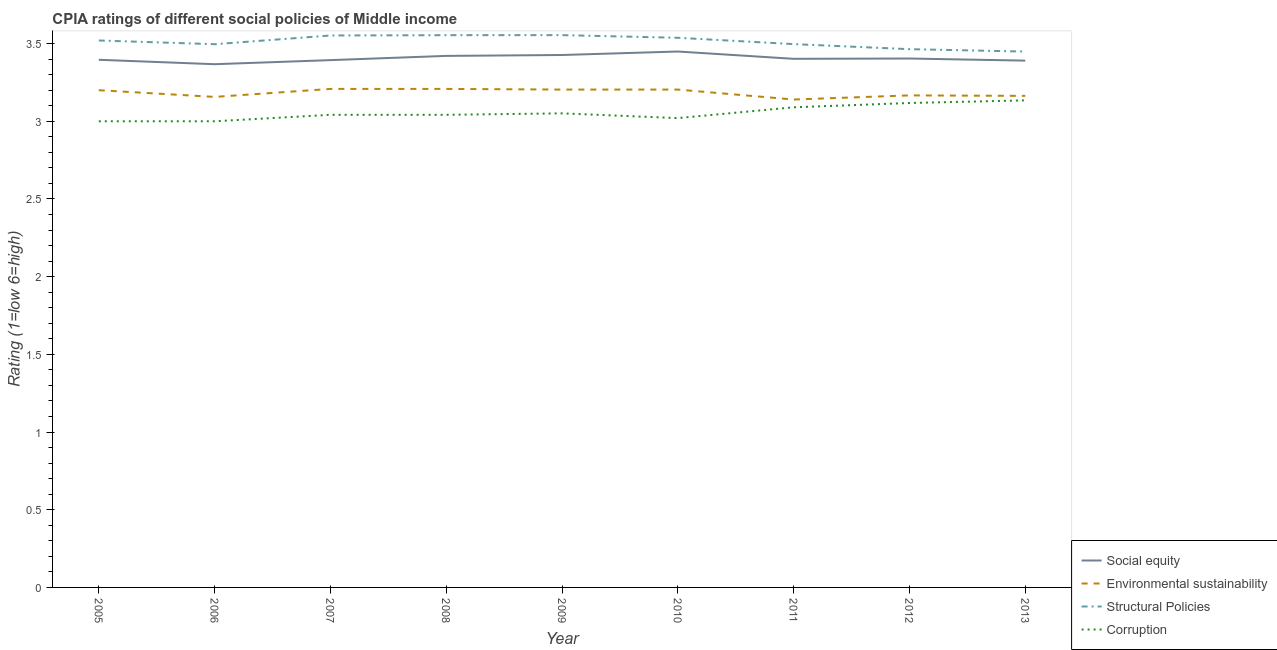How many different coloured lines are there?
Offer a very short reply. 4. Is the number of lines equal to the number of legend labels?
Provide a short and direct response. Yes. What is the cpia rating of corruption in 2009?
Keep it short and to the point. 3.05. Across all years, what is the maximum cpia rating of environmental sustainability?
Ensure brevity in your answer.  3.21. In which year was the cpia rating of environmental sustainability maximum?
Offer a terse response. 2007. In which year was the cpia rating of social equity minimum?
Your answer should be very brief. 2006. What is the total cpia rating of social equity in the graph?
Your answer should be compact. 30.65. What is the difference between the cpia rating of social equity in 2006 and that in 2007?
Your response must be concise. -0.03. What is the difference between the cpia rating of environmental sustainability in 2011 and the cpia rating of structural policies in 2013?
Your answer should be compact. -0.31. What is the average cpia rating of corruption per year?
Give a very brief answer. 3.06. In the year 2007, what is the difference between the cpia rating of social equity and cpia rating of environmental sustainability?
Your answer should be compact. 0.19. What is the ratio of the cpia rating of structural policies in 2009 to that in 2011?
Offer a very short reply. 1.02. Is the cpia rating of corruption in 2005 less than that in 2013?
Provide a short and direct response. Yes. Is the difference between the cpia rating of environmental sustainability in 2008 and 2012 greater than the difference between the cpia rating of corruption in 2008 and 2012?
Make the answer very short. Yes. What is the difference between the highest and the second highest cpia rating of structural policies?
Keep it short and to the point. 0. What is the difference between the highest and the lowest cpia rating of structural policies?
Provide a short and direct response. 0.11. Is the sum of the cpia rating of social equity in 2007 and 2010 greater than the maximum cpia rating of structural policies across all years?
Ensure brevity in your answer.  Yes. Is it the case that in every year, the sum of the cpia rating of social equity and cpia rating of environmental sustainability is greater than the cpia rating of structural policies?
Your answer should be compact. Yes. Is the cpia rating of social equity strictly less than the cpia rating of corruption over the years?
Your answer should be very brief. No. Does the graph contain grids?
Your answer should be very brief. No. How many legend labels are there?
Your answer should be compact. 4. How are the legend labels stacked?
Provide a short and direct response. Vertical. What is the title of the graph?
Offer a very short reply. CPIA ratings of different social policies of Middle income. What is the label or title of the Y-axis?
Make the answer very short. Rating (1=low 6=high). What is the Rating (1=low 6=high) in Social equity in 2005?
Ensure brevity in your answer.  3.4. What is the Rating (1=low 6=high) in Structural Policies in 2005?
Keep it short and to the point. 3.52. What is the Rating (1=low 6=high) of Corruption in 2005?
Offer a terse response. 3. What is the Rating (1=low 6=high) in Social equity in 2006?
Your answer should be very brief. 3.37. What is the Rating (1=low 6=high) in Environmental sustainability in 2006?
Offer a very short reply. 3.16. What is the Rating (1=low 6=high) in Structural Policies in 2006?
Your answer should be compact. 3.5. What is the Rating (1=low 6=high) in Corruption in 2006?
Your answer should be very brief. 3. What is the Rating (1=low 6=high) in Social equity in 2007?
Your response must be concise. 3.39. What is the Rating (1=low 6=high) in Environmental sustainability in 2007?
Keep it short and to the point. 3.21. What is the Rating (1=low 6=high) in Structural Policies in 2007?
Keep it short and to the point. 3.55. What is the Rating (1=low 6=high) in Corruption in 2007?
Offer a terse response. 3.04. What is the Rating (1=low 6=high) of Social equity in 2008?
Make the answer very short. 3.42. What is the Rating (1=low 6=high) in Environmental sustainability in 2008?
Give a very brief answer. 3.21. What is the Rating (1=low 6=high) of Structural Policies in 2008?
Offer a very short reply. 3.55. What is the Rating (1=low 6=high) of Corruption in 2008?
Your response must be concise. 3.04. What is the Rating (1=low 6=high) of Social equity in 2009?
Keep it short and to the point. 3.43. What is the Rating (1=low 6=high) of Environmental sustainability in 2009?
Offer a very short reply. 3.2. What is the Rating (1=low 6=high) in Structural Policies in 2009?
Provide a short and direct response. 3.55. What is the Rating (1=low 6=high) of Corruption in 2009?
Offer a terse response. 3.05. What is the Rating (1=low 6=high) in Social equity in 2010?
Provide a succinct answer. 3.45. What is the Rating (1=low 6=high) in Environmental sustainability in 2010?
Provide a succinct answer. 3.2. What is the Rating (1=low 6=high) of Structural Policies in 2010?
Keep it short and to the point. 3.54. What is the Rating (1=low 6=high) of Corruption in 2010?
Offer a very short reply. 3.02. What is the Rating (1=low 6=high) in Social equity in 2011?
Provide a short and direct response. 3.4. What is the Rating (1=low 6=high) in Environmental sustainability in 2011?
Offer a very short reply. 3.14. What is the Rating (1=low 6=high) in Structural Policies in 2011?
Your answer should be very brief. 3.5. What is the Rating (1=low 6=high) in Corruption in 2011?
Your answer should be compact. 3.09. What is the Rating (1=low 6=high) of Social equity in 2012?
Make the answer very short. 3.4. What is the Rating (1=low 6=high) of Environmental sustainability in 2012?
Give a very brief answer. 3.17. What is the Rating (1=low 6=high) in Structural Policies in 2012?
Provide a short and direct response. 3.46. What is the Rating (1=low 6=high) in Corruption in 2012?
Provide a short and direct response. 3.12. What is the Rating (1=low 6=high) in Social equity in 2013?
Your answer should be compact. 3.39. What is the Rating (1=low 6=high) of Environmental sustainability in 2013?
Your answer should be compact. 3.16. What is the Rating (1=low 6=high) in Structural Policies in 2013?
Your response must be concise. 3.45. What is the Rating (1=low 6=high) of Corruption in 2013?
Your response must be concise. 3.13. Across all years, what is the maximum Rating (1=low 6=high) of Social equity?
Your answer should be compact. 3.45. Across all years, what is the maximum Rating (1=low 6=high) of Environmental sustainability?
Your response must be concise. 3.21. Across all years, what is the maximum Rating (1=low 6=high) in Structural Policies?
Your answer should be very brief. 3.55. Across all years, what is the maximum Rating (1=low 6=high) in Corruption?
Your answer should be very brief. 3.13. Across all years, what is the minimum Rating (1=low 6=high) in Social equity?
Provide a short and direct response. 3.37. Across all years, what is the minimum Rating (1=low 6=high) of Environmental sustainability?
Keep it short and to the point. 3.14. Across all years, what is the minimum Rating (1=low 6=high) of Structural Policies?
Your answer should be very brief. 3.45. Across all years, what is the minimum Rating (1=low 6=high) of Corruption?
Ensure brevity in your answer.  3. What is the total Rating (1=low 6=high) in Social equity in the graph?
Ensure brevity in your answer.  30.65. What is the total Rating (1=low 6=high) in Environmental sustainability in the graph?
Keep it short and to the point. 28.65. What is the total Rating (1=low 6=high) in Structural Policies in the graph?
Keep it short and to the point. 31.62. What is the total Rating (1=low 6=high) in Corruption in the graph?
Offer a very short reply. 27.5. What is the difference between the Rating (1=low 6=high) in Social equity in 2005 and that in 2006?
Keep it short and to the point. 0.03. What is the difference between the Rating (1=low 6=high) in Environmental sustainability in 2005 and that in 2006?
Your response must be concise. 0.04. What is the difference between the Rating (1=low 6=high) of Structural Policies in 2005 and that in 2006?
Offer a very short reply. 0.02. What is the difference between the Rating (1=low 6=high) of Corruption in 2005 and that in 2006?
Your answer should be compact. 0. What is the difference between the Rating (1=low 6=high) in Social equity in 2005 and that in 2007?
Give a very brief answer. 0. What is the difference between the Rating (1=low 6=high) in Environmental sustainability in 2005 and that in 2007?
Provide a succinct answer. -0.01. What is the difference between the Rating (1=low 6=high) in Structural Policies in 2005 and that in 2007?
Your answer should be very brief. -0.03. What is the difference between the Rating (1=low 6=high) in Corruption in 2005 and that in 2007?
Keep it short and to the point. -0.04. What is the difference between the Rating (1=low 6=high) of Social equity in 2005 and that in 2008?
Keep it short and to the point. -0.03. What is the difference between the Rating (1=low 6=high) in Environmental sustainability in 2005 and that in 2008?
Provide a succinct answer. -0.01. What is the difference between the Rating (1=low 6=high) in Structural Policies in 2005 and that in 2008?
Make the answer very short. -0.03. What is the difference between the Rating (1=low 6=high) in Corruption in 2005 and that in 2008?
Your response must be concise. -0.04. What is the difference between the Rating (1=low 6=high) of Social equity in 2005 and that in 2009?
Provide a succinct answer. -0.03. What is the difference between the Rating (1=low 6=high) in Environmental sustainability in 2005 and that in 2009?
Offer a terse response. -0. What is the difference between the Rating (1=low 6=high) in Structural Policies in 2005 and that in 2009?
Make the answer very short. -0.03. What is the difference between the Rating (1=low 6=high) of Corruption in 2005 and that in 2009?
Your answer should be very brief. -0.05. What is the difference between the Rating (1=low 6=high) in Social equity in 2005 and that in 2010?
Ensure brevity in your answer.  -0.05. What is the difference between the Rating (1=low 6=high) of Environmental sustainability in 2005 and that in 2010?
Give a very brief answer. -0. What is the difference between the Rating (1=low 6=high) of Structural Policies in 2005 and that in 2010?
Offer a very short reply. -0.02. What is the difference between the Rating (1=low 6=high) of Corruption in 2005 and that in 2010?
Offer a terse response. -0.02. What is the difference between the Rating (1=low 6=high) in Social equity in 2005 and that in 2011?
Make the answer very short. -0.01. What is the difference between the Rating (1=low 6=high) of Environmental sustainability in 2005 and that in 2011?
Make the answer very short. 0.06. What is the difference between the Rating (1=low 6=high) in Structural Policies in 2005 and that in 2011?
Your answer should be compact. 0.02. What is the difference between the Rating (1=low 6=high) of Corruption in 2005 and that in 2011?
Offer a very short reply. -0.09. What is the difference between the Rating (1=low 6=high) of Social equity in 2005 and that in 2012?
Ensure brevity in your answer.  -0.01. What is the difference between the Rating (1=low 6=high) in Environmental sustainability in 2005 and that in 2012?
Make the answer very short. 0.03. What is the difference between the Rating (1=low 6=high) in Structural Policies in 2005 and that in 2012?
Your answer should be compact. 0.06. What is the difference between the Rating (1=low 6=high) in Corruption in 2005 and that in 2012?
Give a very brief answer. -0.12. What is the difference between the Rating (1=low 6=high) in Social equity in 2005 and that in 2013?
Ensure brevity in your answer.  0.01. What is the difference between the Rating (1=low 6=high) in Environmental sustainability in 2005 and that in 2013?
Provide a short and direct response. 0.04. What is the difference between the Rating (1=low 6=high) in Structural Policies in 2005 and that in 2013?
Your answer should be very brief. 0.07. What is the difference between the Rating (1=low 6=high) in Corruption in 2005 and that in 2013?
Offer a terse response. -0.13. What is the difference between the Rating (1=low 6=high) of Social equity in 2006 and that in 2007?
Provide a short and direct response. -0.03. What is the difference between the Rating (1=low 6=high) in Environmental sustainability in 2006 and that in 2007?
Keep it short and to the point. -0.05. What is the difference between the Rating (1=low 6=high) of Structural Policies in 2006 and that in 2007?
Your answer should be compact. -0.06. What is the difference between the Rating (1=low 6=high) of Corruption in 2006 and that in 2007?
Keep it short and to the point. -0.04. What is the difference between the Rating (1=low 6=high) of Social equity in 2006 and that in 2008?
Your answer should be very brief. -0.05. What is the difference between the Rating (1=low 6=high) in Environmental sustainability in 2006 and that in 2008?
Give a very brief answer. -0.05. What is the difference between the Rating (1=low 6=high) in Structural Policies in 2006 and that in 2008?
Offer a terse response. -0.06. What is the difference between the Rating (1=low 6=high) of Corruption in 2006 and that in 2008?
Give a very brief answer. -0.04. What is the difference between the Rating (1=low 6=high) in Social equity in 2006 and that in 2009?
Provide a succinct answer. -0.06. What is the difference between the Rating (1=low 6=high) of Environmental sustainability in 2006 and that in 2009?
Offer a terse response. -0.05. What is the difference between the Rating (1=low 6=high) of Structural Policies in 2006 and that in 2009?
Make the answer very short. -0.06. What is the difference between the Rating (1=low 6=high) in Corruption in 2006 and that in 2009?
Offer a very short reply. -0.05. What is the difference between the Rating (1=low 6=high) of Social equity in 2006 and that in 2010?
Provide a short and direct response. -0.08. What is the difference between the Rating (1=low 6=high) of Environmental sustainability in 2006 and that in 2010?
Provide a short and direct response. -0.05. What is the difference between the Rating (1=low 6=high) of Structural Policies in 2006 and that in 2010?
Give a very brief answer. -0.04. What is the difference between the Rating (1=low 6=high) in Corruption in 2006 and that in 2010?
Provide a succinct answer. -0.02. What is the difference between the Rating (1=low 6=high) of Social equity in 2006 and that in 2011?
Keep it short and to the point. -0.03. What is the difference between the Rating (1=low 6=high) of Environmental sustainability in 2006 and that in 2011?
Your answer should be very brief. 0.02. What is the difference between the Rating (1=low 6=high) in Structural Policies in 2006 and that in 2011?
Provide a succinct answer. -0. What is the difference between the Rating (1=low 6=high) in Corruption in 2006 and that in 2011?
Give a very brief answer. -0.09. What is the difference between the Rating (1=low 6=high) of Social equity in 2006 and that in 2012?
Provide a short and direct response. -0.04. What is the difference between the Rating (1=low 6=high) of Environmental sustainability in 2006 and that in 2012?
Offer a terse response. -0.01. What is the difference between the Rating (1=low 6=high) in Structural Policies in 2006 and that in 2012?
Make the answer very short. 0.03. What is the difference between the Rating (1=low 6=high) in Corruption in 2006 and that in 2012?
Ensure brevity in your answer.  -0.12. What is the difference between the Rating (1=low 6=high) in Social equity in 2006 and that in 2013?
Provide a succinct answer. -0.02. What is the difference between the Rating (1=low 6=high) in Environmental sustainability in 2006 and that in 2013?
Give a very brief answer. -0.01. What is the difference between the Rating (1=low 6=high) in Structural Policies in 2006 and that in 2013?
Keep it short and to the point. 0.05. What is the difference between the Rating (1=low 6=high) in Corruption in 2006 and that in 2013?
Give a very brief answer. -0.13. What is the difference between the Rating (1=low 6=high) in Social equity in 2007 and that in 2008?
Provide a short and direct response. -0.03. What is the difference between the Rating (1=low 6=high) in Environmental sustainability in 2007 and that in 2008?
Make the answer very short. 0. What is the difference between the Rating (1=low 6=high) in Structural Policies in 2007 and that in 2008?
Make the answer very short. -0. What is the difference between the Rating (1=low 6=high) of Corruption in 2007 and that in 2008?
Make the answer very short. 0. What is the difference between the Rating (1=low 6=high) in Social equity in 2007 and that in 2009?
Provide a short and direct response. -0.03. What is the difference between the Rating (1=low 6=high) of Environmental sustainability in 2007 and that in 2009?
Provide a succinct answer. 0. What is the difference between the Rating (1=low 6=high) of Structural Policies in 2007 and that in 2009?
Ensure brevity in your answer.  -0. What is the difference between the Rating (1=low 6=high) in Corruption in 2007 and that in 2009?
Your answer should be very brief. -0.01. What is the difference between the Rating (1=low 6=high) in Social equity in 2007 and that in 2010?
Your answer should be very brief. -0.06. What is the difference between the Rating (1=low 6=high) of Environmental sustainability in 2007 and that in 2010?
Keep it short and to the point. 0. What is the difference between the Rating (1=low 6=high) in Structural Policies in 2007 and that in 2010?
Make the answer very short. 0.01. What is the difference between the Rating (1=low 6=high) in Corruption in 2007 and that in 2010?
Make the answer very short. 0.02. What is the difference between the Rating (1=low 6=high) in Social equity in 2007 and that in 2011?
Ensure brevity in your answer.  -0.01. What is the difference between the Rating (1=low 6=high) in Environmental sustainability in 2007 and that in 2011?
Keep it short and to the point. 0.07. What is the difference between the Rating (1=low 6=high) in Structural Policies in 2007 and that in 2011?
Provide a succinct answer. 0.06. What is the difference between the Rating (1=low 6=high) of Corruption in 2007 and that in 2011?
Provide a succinct answer. -0.05. What is the difference between the Rating (1=low 6=high) of Social equity in 2007 and that in 2012?
Your answer should be compact. -0.01. What is the difference between the Rating (1=low 6=high) of Environmental sustainability in 2007 and that in 2012?
Make the answer very short. 0.04. What is the difference between the Rating (1=low 6=high) of Structural Policies in 2007 and that in 2012?
Make the answer very short. 0.09. What is the difference between the Rating (1=low 6=high) in Corruption in 2007 and that in 2012?
Your response must be concise. -0.08. What is the difference between the Rating (1=low 6=high) in Social equity in 2007 and that in 2013?
Make the answer very short. 0. What is the difference between the Rating (1=low 6=high) of Environmental sustainability in 2007 and that in 2013?
Your response must be concise. 0.04. What is the difference between the Rating (1=low 6=high) of Structural Policies in 2007 and that in 2013?
Give a very brief answer. 0.1. What is the difference between the Rating (1=low 6=high) of Corruption in 2007 and that in 2013?
Your answer should be very brief. -0.09. What is the difference between the Rating (1=low 6=high) in Social equity in 2008 and that in 2009?
Ensure brevity in your answer.  -0.01. What is the difference between the Rating (1=low 6=high) in Environmental sustainability in 2008 and that in 2009?
Give a very brief answer. 0. What is the difference between the Rating (1=low 6=high) in Structural Policies in 2008 and that in 2009?
Offer a very short reply. -0. What is the difference between the Rating (1=low 6=high) of Corruption in 2008 and that in 2009?
Make the answer very short. -0.01. What is the difference between the Rating (1=low 6=high) in Social equity in 2008 and that in 2010?
Your answer should be compact. -0.03. What is the difference between the Rating (1=low 6=high) in Environmental sustainability in 2008 and that in 2010?
Make the answer very short. 0. What is the difference between the Rating (1=low 6=high) in Structural Policies in 2008 and that in 2010?
Provide a succinct answer. 0.02. What is the difference between the Rating (1=low 6=high) of Corruption in 2008 and that in 2010?
Offer a very short reply. 0.02. What is the difference between the Rating (1=low 6=high) of Social equity in 2008 and that in 2011?
Provide a short and direct response. 0.02. What is the difference between the Rating (1=low 6=high) of Environmental sustainability in 2008 and that in 2011?
Your response must be concise. 0.07. What is the difference between the Rating (1=low 6=high) in Structural Policies in 2008 and that in 2011?
Keep it short and to the point. 0.06. What is the difference between the Rating (1=low 6=high) of Corruption in 2008 and that in 2011?
Your response must be concise. -0.05. What is the difference between the Rating (1=low 6=high) in Social equity in 2008 and that in 2012?
Offer a very short reply. 0.02. What is the difference between the Rating (1=low 6=high) of Environmental sustainability in 2008 and that in 2012?
Make the answer very short. 0.04. What is the difference between the Rating (1=low 6=high) in Structural Policies in 2008 and that in 2012?
Offer a terse response. 0.09. What is the difference between the Rating (1=low 6=high) in Corruption in 2008 and that in 2012?
Give a very brief answer. -0.08. What is the difference between the Rating (1=low 6=high) in Social equity in 2008 and that in 2013?
Keep it short and to the point. 0.03. What is the difference between the Rating (1=low 6=high) in Environmental sustainability in 2008 and that in 2013?
Your answer should be compact. 0.04. What is the difference between the Rating (1=low 6=high) of Structural Policies in 2008 and that in 2013?
Keep it short and to the point. 0.11. What is the difference between the Rating (1=low 6=high) in Corruption in 2008 and that in 2013?
Keep it short and to the point. -0.09. What is the difference between the Rating (1=low 6=high) of Social equity in 2009 and that in 2010?
Offer a terse response. -0.02. What is the difference between the Rating (1=low 6=high) in Structural Policies in 2009 and that in 2010?
Your answer should be compact. 0.02. What is the difference between the Rating (1=low 6=high) in Corruption in 2009 and that in 2010?
Your response must be concise. 0.03. What is the difference between the Rating (1=low 6=high) of Social equity in 2009 and that in 2011?
Provide a succinct answer. 0.02. What is the difference between the Rating (1=low 6=high) in Environmental sustainability in 2009 and that in 2011?
Provide a short and direct response. 0.06. What is the difference between the Rating (1=low 6=high) of Structural Policies in 2009 and that in 2011?
Your answer should be very brief. 0.06. What is the difference between the Rating (1=low 6=high) in Corruption in 2009 and that in 2011?
Your response must be concise. -0.04. What is the difference between the Rating (1=low 6=high) of Social equity in 2009 and that in 2012?
Your response must be concise. 0.02. What is the difference between the Rating (1=low 6=high) of Environmental sustainability in 2009 and that in 2012?
Provide a short and direct response. 0.04. What is the difference between the Rating (1=low 6=high) in Structural Policies in 2009 and that in 2012?
Your answer should be compact. 0.09. What is the difference between the Rating (1=low 6=high) in Corruption in 2009 and that in 2012?
Make the answer very short. -0.07. What is the difference between the Rating (1=low 6=high) in Social equity in 2009 and that in 2013?
Your answer should be very brief. 0.04. What is the difference between the Rating (1=low 6=high) in Environmental sustainability in 2009 and that in 2013?
Give a very brief answer. 0.04. What is the difference between the Rating (1=low 6=high) in Structural Policies in 2009 and that in 2013?
Provide a succinct answer. 0.11. What is the difference between the Rating (1=low 6=high) of Corruption in 2009 and that in 2013?
Offer a very short reply. -0.08. What is the difference between the Rating (1=low 6=high) in Social equity in 2010 and that in 2011?
Ensure brevity in your answer.  0.05. What is the difference between the Rating (1=low 6=high) of Environmental sustainability in 2010 and that in 2011?
Keep it short and to the point. 0.06. What is the difference between the Rating (1=low 6=high) of Structural Policies in 2010 and that in 2011?
Offer a very short reply. 0.04. What is the difference between the Rating (1=low 6=high) in Corruption in 2010 and that in 2011?
Provide a short and direct response. -0.07. What is the difference between the Rating (1=low 6=high) of Social equity in 2010 and that in 2012?
Ensure brevity in your answer.  0.05. What is the difference between the Rating (1=low 6=high) in Environmental sustainability in 2010 and that in 2012?
Offer a very short reply. 0.04. What is the difference between the Rating (1=low 6=high) in Structural Policies in 2010 and that in 2012?
Give a very brief answer. 0.07. What is the difference between the Rating (1=low 6=high) of Corruption in 2010 and that in 2012?
Offer a very short reply. -0.1. What is the difference between the Rating (1=low 6=high) of Social equity in 2010 and that in 2013?
Offer a terse response. 0.06. What is the difference between the Rating (1=low 6=high) in Environmental sustainability in 2010 and that in 2013?
Your response must be concise. 0.04. What is the difference between the Rating (1=low 6=high) in Structural Policies in 2010 and that in 2013?
Give a very brief answer. 0.09. What is the difference between the Rating (1=low 6=high) of Corruption in 2010 and that in 2013?
Ensure brevity in your answer.  -0.11. What is the difference between the Rating (1=low 6=high) of Social equity in 2011 and that in 2012?
Provide a succinct answer. -0. What is the difference between the Rating (1=low 6=high) of Environmental sustainability in 2011 and that in 2012?
Provide a succinct answer. -0.03. What is the difference between the Rating (1=low 6=high) in Structural Policies in 2011 and that in 2012?
Keep it short and to the point. 0.03. What is the difference between the Rating (1=low 6=high) in Corruption in 2011 and that in 2012?
Provide a short and direct response. -0.03. What is the difference between the Rating (1=low 6=high) in Social equity in 2011 and that in 2013?
Provide a succinct answer. 0.01. What is the difference between the Rating (1=low 6=high) in Environmental sustainability in 2011 and that in 2013?
Provide a succinct answer. -0.02. What is the difference between the Rating (1=low 6=high) of Structural Policies in 2011 and that in 2013?
Give a very brief answer. 0.05. What is the difference between the Rating (1=low 6=high) of Corruption in 2011 and that in 2013?
Make the answer very short. -0.04. What is the difference between the Rating (1=low 6=high) in Social equity in 2012 and that in 2013?
Provide a short and direct response. 0.01. What is the difference between the Rating (1=low 6=high) of Environmental sustainability in 2012 and that in 2013?
Offer a very short reply. 0. What is the difference between the Rating (1=low 6=high) in Structural Policies in 2012 and that in 2013?
Make the answer very short. 0.02. What is the difference between the Rating (1=low 6=high) in Corruption in 2012 and that in 2013?
Offer a terse response. -0.02. What is the difference between the Rating (1=low 6=high) in Social equity in 2005 and the Rating (1=low 6=high) in Environmental sustainability in 2006?
Keep it short and to the point. 0.24. What is the difference between the Rating (1=low 6=high) of Social equity in 2005 and the Rating (1=low 6=high) of Structural Policies in 2006?
Your response must be concise. -0.1. What is the difference between the Rating (1=low 6=high) in Social equity in 2005 and the Rating (1=low 6=high) in Corruption in 2006?
Make the answer very short. 0.4. What is the difference between the Rating (1=low 6=high) in Environmental sustainability in 2005 and the Rating (1=low 6=high) in Structural Policies in 2006?
Provide a succinct answer. -0.3. What is the difference between the Rating (1=low 6=high) of Structural Policies in 2005 and the Rating (1=low 6=high) of Corruption in 2006?
Ensure brevity in your answer.  0.52. What is the difference between the Rating (1=low 6=high) of Social equity in 2005 and the Rating (1=low 6=high) of Environmental sustainability in 2007?
Provide a short and direct response. 0.19. What is the difference between the Rating (1=low 6=high) of Social equity in 2005 and the Rating (1=low 6=high) of Structural Policies in 2007?
Ensure brevity in your answer.  -0.16. What is the difference between the Rating (1=low 6=high) of Social equity in 2005 and the Rating (1=low 6=high) of Corruption in 2007?
Provide a succinct answer. 0.35. What is the difference between the Rating (1=low 6=high) of Environmental sustainability in 2005 and the Rating (1=low 6=high) of Structural Policies in 2007?
Keep it short and to the point. -0.35. What is the difference between the Rating (1=low 6=high) in Environmental sustainability in 2005 and the Rating (1=low 6=high) in Corruption in 2007?
Make the answer very short. 0.16. What is the difference between the Rating (1=low 6=high) in Structural Policies in 2005 and the Rating (1=low 6=high) in Corruption in 2007?
Your answer should be very brief. 0.48. What is the difference between the Rating (1=low 6=high) of Social equity in 2005 and the Rating (1=low 6=high) of Environmental sustainability in 2008?
Your response must be concise. 0.19. What is the difference between the Rating (1=low 6=high) in Social equity in 2005 and the Rating (1=low 6=high) in Structural Policies in 2008?
Provide a succinct answer. -0.16. What is the difference between the Rating (1=low 6=high) in Social equity in 2005 and the Rating (1=low 6=high) in Corruption in 2008?
Provide a short and direct response. 0.35. What is the difference between the Rating (1=low 6=high) of Environmental sustainability in 2005 and the Rating (1=low 6=high) of Structural Policies in 2008?
Your answer should be very brief. -0.35. What is the difference between the Rating (1=low 6=high) of Environmental sustainability in 2005 and the Rating (1=low 6=high) of Corruption in 2008?
Make the answer very short. 0.16. What is the difference between the Rating (1=low 6=high) of Structural Policies in 2005 and the Rating (1=low 6=high) of Corruption in 2008?
Keep it short and to the point. 0.48. What is the difference between the Rating (1=low 6=high) of Social equity in 2005 and the Rating (1=low 6=high) of Environmental sustainability in 2009?
Give a very brief answer. 0.19. What is the difference between the Rating (1=low 6=high) in Social equity in 2005 and the Rating (1=low 6=high) in Structural Policies in 2009?
Ensure brevity in your answer.  -0.16. What is the difference between the Rating (1=low 6=high) of Social equity in 2005 and the Rating (1=low 6=high) of Corruption in 2009?
Make the answer very short. 0.34. What is the difference between the Rating (1=low 6=high) of Environmental sustainability in 2005 and the Rating (1=low 6=high) of Structural Policies in 2009?
Make the answer very short. -0.35. What is the difference between the Rating (1=low 6=high) in Environmental sustainability in 2005 and the Rating (1=low 6=high) in Corruption in 2009?
Provide a succinct answer. 0.15. What is the difference between the Rating (1=low 6=high) in Structural Policies in 2005 and the Rating (1=low 6=high) in Corruption in 2009?
Your answer should be compact. 0.47. What is the difference between the Rating (1=low 6=high) of Social equity in 2005 and the Rating (1=low 6=high) of Environmental sustainability in 2010?
Offer a very short reply. 0.19. What is the difference between the Rating (1=low 6=high) of Social equity in 2005 and the Rating (1=low 6=high) of Structural Policies in 2010?
Your response must be concise. -0.14. What is the difference between the Rating (1=low 6=high) in Social equity in 2005 and the Rating (1=low 6=high) in Corruption in 2010?
Your answer should be very brief. 0.38. What is the difference between the Rating (1=low 6=high) of Environmental sustainability in 2005 and the Rating (1=low 6=high) of Structural Policies in 2010?
Offer a terse response. -0.34. What is the difference between the Rating (1=low 6=high) in Environmental sustainability in 2005 and the Rating (1=low 6=high) in Corruption in 2010?
Provide a succinct answer. 0.18. What is the difference between the Rating (1=low 6=high) of Structural Policies in 2005 and the Rating (1=low 6=high) of Corruption in 2010?
Your response must be concise. 0.5. What is the difference between the Rating (1=low 6=high) of Social equity in 2005 and the Rating (1=low 6=high) of Environmental sustainability in 2011?
Give a very brief answer. 0.26. What is the difference between the Rating (1=low 6=high) of Social equity in 2005 and the Rating (1=low 6=high) of Structural Policies in 2011?
Provide a short and direct response. -0.1. What is the difference between the Rating (1=low 6=high) of Social equity in 2005 and the Rating (1=low 6=high) of Corruption in 2011?
Provide a succinct answer. 0.31. What is the difference between the Rating (1=low 6=high) in Environmental sustainability in 2005 and the Rating (1=low 6=high) in Structural Policies in 2011?
Ensure brevity in your answer.  -0.3. What is the difference between the Rating (1=low 6=high) of Environmental sustainability in 2005 and the Rating (1=low 6=high) of Corruption in 2011?
Make the answer very short. 0.11. What is the difference between the Rating (1=low 6=high) in Structural Policies in 2005 and the Rating (1=low 6=high) in Corruption in 2011?
Provide a succinct answer. 0.43. What is the difference between the Rating (1=low 6=high) of Social equity in 2005 and the Rating (1=low 6=high) of Environmental sustainability in 2012?
Give a very brief answer. 0.23. What is the difference between the Rating (1=low 6=high) in Social equity in 2005 and the Rating (1=low 6=high) in Structural Policies in 2012?
Provide a short and direct response. -0.07. What is the difference between the Rating (1=low 6=high) of Social equity in 2005 and the Rating (1=low 6=high) of Corruption in 2012?
Provide a succinct answer. 0.28. What is the difference between the Rating (1=low 6=high) in Environmental sustainability in 2005 and the Rating (1=low 6=high) in Structural Policies in 2012?
Your response must be concise. -0.26. What is the difference between the Rating (1=low 6=high) in Environmental sustainability in 2005 and the Rating (1=low 6=high) in Corruption in 2012?
Give a very brief answer. 0.08. What is the difference between the Rating (1=low 6=high) in Structural Policies in 2005 and the Rating (1=low 6=high) in Corruption in 2012?
Provide a short and direct response. 0.4. What is the difference between the Rating (1=low 6=high) of Social equity in 2005 and the Rating (1=low 6=high) of Environmental sustainability in 2013?
Your response must be concise. 0.23. What is the difference between the Rating (1=low 6=high) of Social equity in 2005 and the Rating (1=low 6=high) of Structural Policies in 2013?
Make the answer very short. -0.05. What is the difference between the Rating (1=low 6=high) of Social equity in 2005 and the Rating (1=low 6=high) of Corruption in 2013?
Your response must be concise. 0.26. What is the difference between the Rating (1=low 6=high) in Environmental sustainability in 2005 and the Rating (1=low 6=high) in Structural Policies in 2013?
Your answer should be very brief. -0.25. What is the difference between the Rating (1=low 6=high) of Environmental sustainability in 2005 and the Rating (1=low 6=high) of Corruption in 2013?
Keep it short and to the point. 0.07. What is the difference between the Rating (1=low 6=high) in Structural Policies in 2005 and the Rating (1=low 6=high) in Corruption in 2013?
Ensure brevity in your answer.  0.39. What is the difference between the Rating (1=low 6=high) of Social equity in 2006 and the Rating (1=low 6=high) of Environmental sustainability in 2007?
Make the answer very short. 0.16. What is the difference between the Rating (1=low 6=high) of Social equity in 2006 and the Rating (1=low 6=high) of Structural Policies in 2007?
Ensure brevity in your answer.  -0.18. What is the difference between the Rating (1=low 6=high) in Social equity in 2006 and the Rating (1=low 6=high) in Corruption in 2007?
Offer a very short reply. 0.33. What is the difference between the Rating (1=low 6=high) of Environmental sustainability in 2006 and the Rating (1=low 6=high) of Structural Policies in 2007?
Provide a short and direct response. -0.4. What is the difference between the Rating (1=low 6=high) in Environmental sustainability in 2006 and the Rating (1=low 6=high) in Corruption in 2007?
Give a very brief answer. 0.12. What is the difference between the Rating (1=low 6=high) in Structural Policies in 2006 and the Rating (1=low 6=high) in Corruption in 2007?
Make the answer very short. 0.45. What is the difference between the Rating (1=low 6=high) of Social equity in 2006 and the Rating (1=low 6=high) of Environmental sustainability in 2008?
Give a very brief answer. 0.16. What is the difference between the Rating (1=low 6=high) in Social equity in 2006 and the Rating (1=low 6=high) in Structural Policies in 2008?
Offer a very short reply. -0.19. What is the difference between the Rating (1=low 6=high) in Social equity in 2006 and the Rating (1=low 6=high) in Corruption in 2008?
Your answer should be very brief. 0.33. What is the difference between the Rating (1=low 6=high) of Environmental sustainability in 2006 and the Rating (1=low 6=high) of Structural Policies in 2008?
Keep it short and to the point. -0.4. What is the difference between the Rating (1=low 6=high) in Environmental sustainability in 2006 and the Rating (1=low 6=high) in Corruption in 2008?
Ensure brevity in your answer.  0.12. What is the difference between the Rating (1=low 6=high) of Structural Policies in 2006 and the Rating (1=low 6=high) of Corruption in 2008?
Your response must be concise. 0.45. What is the difference between the Rating (1=low 6=high) in Social equity in 2006 and the Rating (1=low 6=high) in Environmental sustainability in 2009?
Make the answer very short. 0.16. What is the difference between the Rating (1=low 6=high) in Social equity in 2006 and the Rating (1=low 6=high) in Structural Policies in 2009?
Provide a short and direct response. -0.19. What is the difference between the Rating (1=low 6=high) of Social equity in 2006 and the Rating (1=low 6=high) of Corruption in 2009?
Ensure brevity in your answer.  0.32. What is the difference between the Rating (1=low 6=high) of Environmental sustainability in 2006 and the Rating (1=low 6=high) of Structural Policies in 2009?
Offer a very short reply. -0.4. What is the difference between the Rating (1=low 6=high) of Environmental sustainability in 2006 and the Rating (1=low 6=high) of Corruption in 2009?
Keep it short and to the point. 0.11. What is the difference between the Rating (1=low 6=high) in Structural Policies in 2006 and the Rating (1=low 6=high) in Corruption in 2009?
Your answer should be very brief. 0.45. What is the difference between the Rating (1=low 6=high) in Social equity in 2006 and the Rating (1=low 6=high) in Environmental sustainability in 2010?
Ensure brevity in your answer.  0.16. What is the difference between the Rating (1=low 6=high) of Social equity in 2006 and the Rating (1=low 6=high) of Structural Policies in 2010?
Provide a short and direct response. -0.17. What is the difference between the Rating (1=low 6=high) in Social equity in 2006 and the Rating (1=low 6=high) in Corruption in 2010?
Your answer should be compact. 0.35. What is the difference between the Rating (1=low 6=high) of Environmental sustainability in 2006 and the Rating (1=low 6=high) of Structural Policies in 2010?
Your answer should be very brief. -0.38. What is the difference between the Rating (1=low 6=high) of Environmental sustainability in 2006 and the Rating (1=low 6=high) of Corruption in 2010?
Your response must be concise. 0.14. What is the difference between the Rating (1=low 6=high) in Structural Policies in 2006 and the Rating (1=low 6=high) in Corruption in 2010?
Your response must be concise. 0.48. What is the difference between the Rating (1=low 6=high) of Social equity in 2006 and the Rating (1=low 6=high) of Environmental sustainability in 2011?
Offer a very short reply. 0.23. What is the difference between the Rating (1=low 6=high) of Social equity in 2006 and the Rating (1=low 6=high) of Structural Policies in 2011?
Provide a succinct answer. -0.13. What is the difference between the Rating (1=low 6=high) in Social equity in 2006 and the Rating (1=low 6=high) in Corruption in 2011?
Provide a succinct answer. 0.28. What is the difference between the Rating (1=low 6=high) in Environmental sustainability in 2006 and the Rating (1=low 6=high) in Structural Policies in 2011?
Provide a succinct answer. -0.34. What is the difference between the Rating (1=low 6=high) of Environmental sustainability in 2006 and the Rating (1=low 6=high) of Corruption in 2011?
Offer a very short reply. 0.07. What is the difference between the Rating (1=low 6=high) of Structural Policies in 2006 and the Rating (1=low 6=high) of Corruption in 2011?
Offer a very short reply. 0.41. What is the difference between the Rating (1=low 6=high) of Social equity in 2006 and the Rating (1=low 6=high) of Environmental sustainability in 2012?
Offer a terse response. 0.2. What is the difference between the Rating (1=low 6=high) of Social equity in 2006 and the Rating (1=low 6=high) of Structural Policies in 2012?
Your answer should be compact. -0.1. What is the difference between the Rating (1=low 6=high) of Social equity in 2006 and the Rating (1=low 6=high) of Corruption in 2012?
Ensure brevity in your answer.  0.25. What is the difference between the Rating (1=low 6=high) in Environmental sustainability in 2006 and the Rating (1=low 6=high) in Structural Policies in 2012?
Make the answer very short. -0.31. What is the difference between the Rating (1=low 6=high) in Environmental sustainability in 2006 and the Rating (1=low 6=high) in Corruption in 2012?
Ensure brevity in your answer.  0.04. What is the difference between the Rating (1=low 6=high) of Structural Policies in 2006 and the Rating (1=low 6=high) of Corruption in 2012?
Your response must be concise. 0.38. What is the difference between the Rating (1=low 6=high) in Social equity in 2006 and the Rating (1=low 6=high) in Environmental sustainability in 2013?
Your answer should be compact. 0.2. What is the difference between the Rating (1=low 6=high) in Social equity in 2006 and the Rating (1=low 6=high) in Structural Policies in 2013?
Provide a succinct answer. -0.08. What is the difference between the Rating (1=low 6=high) of Social equity in 2006 and the Rating (1=low 6=high) of Corruption in 2013?
Keep it short and to the point. 0.23. What is the difference between the Rating (1=low 6=high) of Environmental sustainability in 2006 and the Rating (1=low 6=high) of Structural Policies in 2013?
Keep it short and to the point. -0.29. What is the difference between the Rating (1=low 6=high) of Environmental sustainability in 2006 and the Rating (1=low 6=high) of Corruption in 2013?
Offer a very short reply. 0.02. What is the difference between the Rating (1=low 6=high) of Structural Policies in 2006 and the Rating (1=low 6=high) of Corruption in 2013?
Provide a succinct answer. 0.36. What is the difference between the Rating (1=low 6=high) of Social equity in 2007 and the Rating (1=low 6=high) of Environmental sustainability in 2008?
Ensure brevity in your answer.  0.19. What is the difference between the Rating (1=low 6=high) of Social equity in 2007 and the Rating (1=low 6=high) of Structural Policies in 2008?
Offer a terse response. -0.16. What is the difference between the Rating (1=low 6=high) in Social equity in 2007 and the Rating (1=low 6=high) in Corruption in 2008?
Your answer should be compact. 0.35. What is the difference between the Rating (1=low 6=high) of Environmental sustainability in 2007 and the Rating (1=low 6=high) of Structural Policies in 2008?
Offer a very short reply. -0.35. What is the difference between the Rating (1=low 6=high) of Environmental sustainability in 2007 and the Rating (1=low 6=high) of Corruption in 2008?
Give a very brief answer. 0.17. What is the difference between the Rating (1=low 6=high) in Structural Policies in 2007 and the Rating (1=low 6=high) in Corruption in 2008?
Offer a very short reply. 0.51. What is the difference between the Rating (1=low 6=high) of Social equity in 2007 and the Rating (1=low 6=high) of Environmental sustainability in 2009?
Your answer should be compact. 0.19. What is the difference between the Rating (1=low 6=high) of Social equity in 2007 and the Rating (1=low 6=high) of Structural Policies in 2009?
Provide a succinct answer. -0.16. What is the difference between the Rating (1=low 6=high) of Social equity in 2007 and the Rating (1=low 6=high) of Corruption in 2009?
Your answer should be compact. 0.34. What is the difference between the Rating (1=low 6=high) of Environmental sustainability in 2007 and the Rating (1=low 6=high) of Structural Policies in 2009?
Offer a very short reply. -0.35. What is the difference between the Rating (1=low 6=high) of Environmental sustainability in 2007 and the Rating (1=low 6=high) of Corruption in 2009?
Your response must be concise. 0.16. What is the difference between the Rating (1=low 6=high) in Structural Policies in 2007 and the Rating (1=low 6=high) in Corruption in 2009?
Your answer should be compact. 0.5. What is the difference between the Rating (1=low 6=high) of Social equity in 2007 and the Rating (1=low 6=high) of Environmental sustainability in 2010?
Your response must be concise. 0.19. What is the difference between the Rating (1=low 6=high) of Social equity in 2007 and the Rating (1=low 6=high) of Structural Policies in 2010?
Your response must be concise. -0.14. What is the difference between the Rating (1=low 6=high) of Social equity in 2007 and the Rating (1=low 6=high) of Corruption in 2010?
Make the answer very short. 0.37. What is the difference between the Rating (1=low 6=high) in Environmental sustainability in 2007 and the Rating (1=low 6=high) in Structural Policies in 2010?
Your answer should be very brief. -0.33. What is the difference between the Rating (1=low 6=high) in Environmental sustainability in 2007 and the Rating (1=low 6=high) in Corruption in 2010?
Your response must be concise. 0.19. What is the difference between the Rating (1=low 6=high) of Structural Policies in 2007 and the Rating (1=low 6=high) of Corruption in 2010?
Ensure brevity in your answer.  0.53. What is the difference between the Rating (1=low 6=high) in Social equity in 2007 and the Rating (1=low 6=high) in Environmental sustainability in 2011?
Your response must be concise. 0.25. What is the difference between the Rating (1=low 6=high) of Social equity in 2007 and the Rating (1=low 6=high) of Structural Policies in 2011?
Keep it short and to the point. -0.1. What is the difference between the Rating (1=low 6=high) of Social equity in 2007 and the Rating (1=low 6=high) of Corruption in 2011?
Your response must be concise. 0.3. What is the difference between the Rating (1=low 6=high) in Environmental sustainability in 2007 and the Rating (1=low 6=high) in Structural Policies in 2011?
Your answer should be very brief. -0.29. What is the difference between the Rating (1=low 6=high) in Environmental sustainability in 2007 and the Rating (1=low 6=high) in Corruption in 2011?
Your answer should be compact. 0.12. What is the difference between the Rating (1=low 6=high) of Structural Policies in 2007 and the Rating (1=low 6=high) of Corruption in 2011?
Offer a very short reply. 0.46. What is the difference between the Rating (1=low 6=high) in Social equity in 2007 and the Rating (1=low 6=high) in Environmental sustainability in 2012?
Your response must be concise. 0.23. What is the difference between the Rating (1=low 6=high) of Social equity in 2007 and the Rating (1=low 6=high) of Structural Policies in 2012?
Keep it short and to the point. -0.07. What is the difference between the Rating (1=low 6=high) in Social equity in 2007 and the Rating (1=low 6=high) in Corruption in 2012?
Your answer should be very brief. 0.28. What is the difference between the Rating (1=low 6=high) of Environmental sustainability in 2007 and the Rating (1=low 6=high) of Structural Policies in 2012?
Ensure brevity in your answer.  -0.26. What is the difference between the Rating (1=low 6=high) in Environmental sustainability in 2007 and the Rating (1=low 6=high) in Corruption in 2012?
Provide a succinct answer. 0.09. What is the difference between the Rating (1=low 6=high) of Structural Policies in 2007 and the Rating (1=low 6=high) of Corruption in 2012?
Your answer should be compact. 0.43. What is the difference between the Rating (1=low 6=high) in Social equity in 2007 and the Rating (1=low 6=high) in Environmental sustainability in 2013?
Your answer should be very brief. 0.23. What is the difference between the Rating (1=low 6=high) of Social equity in 2007 and the Rating (1=low 6=high) of Structural Policies in 2013?
Offer a very short reply. -0.06. What is the difference between the Rating (1=low 6=high) in Social equity in 2007 and the Rating (1=low 6=high) in Corruption in 2013?
Ensure brevity in your answer.  0.26. What is the difference between the Rating (1=low 6=high) of Environmental sustainability in 2007 and the Rating (1=low 6=high) of Structural Policies in 2013?
Make the answer very short. -0.24. What is the difference between the Rating (1=low 6=high) of Environmental sustainability in 2007 and the Rating (1=low 6=high) of Corruption in 2013?
Provide a short and direct response. 0.07. What is the difference between the Rating (1=low 6=high) of Structural Policies in 2007 and the Rating (1=low 6=high) of Corruption in 2013?
Ensure brevity in your answer.  0.42. What is the difference between the Rating (1=low 6=high) in Social equity in 2008 and the Rating (1=low 6=high) in Environmental sustainability in 2009?
Provide a short and direct response. 0.22. What is the difference between the Rating (1=low 6=high) of Social equity in 2008 and the Rating (1=low 6=high) of Structural Policies in 2009?
Provide a short and direct response. -0.13. What is the difference between the Rating (1=low 6=high) in Social equity in 2008 and the Rating (1=low 6=high) in Corruption in 2009?
Keep it short and to the point. 0.37. What is the difference between the Rating (1=low 6=high) of Environmental sustainability in 2008 and the Rating (1=low 6=high) of Structural Policies in 2009?
Keep it short and to the point. -0.35. What is the difference between the Rating (1=low 6=high) in Environmental sustainability in 2008 and the Rating (1=low 6=high) in Corruption in 2009?
Give a very brief answer. 0.16. What is the difference between the Rating (1=low 6=high) in Structural Policies in 2008 and the Rating (1=low 6=high) in Corruption in 2009?
Offer a very short reply. 0.5. What is the difference between the Rating (1=low 6=high) of Social equity in 2008 and the Rating (1=low 6=high) of Environmental sustainability in 2010?
Provide a succinct answer. 0.22. What is the difference between the Rating (1=low 6=high) of Social equity in 2008 and the Rating (1=low 6=high) of Structural Policies in 2010?
Your answer should be compact. -0.12. What is the difference between the Rating (1=low 6=high) of Social equity in 2008 and the Rating (1=low 6=high) of Corruption in 2010?
Your answer should be very brief. 0.4. What is the difference between the Rating (1=low 6=high) of Environmental sustainability in 2008 and the Rating (1=low 6=high) of Structural Policies in 2010?
Provide a succinct answer. -0.33. What is the difference between the Rating (1=low 6=high) of Environmental sustainability in 2008 and the Rating (1=low 6=high) of Corruption in 2010?
Provide a succinct answer. 0.19. What is the difference between the Rating (1=low 6=high) in Structural Policies in 2008 and the Rating (1=low 6=high) in Corruption in 2010?
Offer a very short reply. 0.53. What is the difference between the Rating (1=low 6=high) of Social equity in 2008 and the Rating (1=low 6=high) of Environmental sustainability in 2011?
Ensure brevity in your answer.  0.28. What is the difference between the Rating (1=low 6=high) of Social equity in 2008 and the Rating (1=low 6=high) of Structural Policies in 2011?
Your response must be concise. -0.08. What is the difference between the Rating (1=low 6=high) in Social equity in 2008 and the Rating (1=low 6=high) in Corruption in 2011?
Offer a terse response. 0.33. What is the difference between the Rating (1=low 6=high) in Environmental sustainability in 2008 and the Rating (1=low 6=high) in Structural Policies in 2011?
Offer a very short reply. -0.29. What is the difference between the Rating (1=low 6=high) of Environmental sustainability in 2008 and the Rating (1=low 6=high) of Corruption in 2011?
Offer a terse response. 0.12. What is the difference between the Rating (1=low 6=high) of Structural Policies in 2008 and the Rating (1=low 6=high) of Corruption in 2011?
Your response must be concise. 0.46. What is the difference between the Rating (1=low 6=high) in Social equity in 2008 and the Rating (1=low 6=high) in Environmental sustainability in 2012?
Provide a succinct answer. 0.25. What is the difference between the Rating (1=low 6=high) in Social equity in 2008 and the Rating (1=low 6=high) in Structural Policies in 2012?
Your answer should be very brief. -0.04. What is the difference between the Rating (1=low 6=high) of Social equity in 2008 and the Rating (1=low 6=high) of Corruption in 2012?
Your answer should be compact. 0.3. What is the difference between the Rating (1=low 6=high) of Environmental sustainability in 2008 and the Rating (1=low 6=high) of Structural Policies in 2012?
Provide a succinct answer. -0.26. What is the difference between the Rating (1=low 6=high) of Environmental sustainability in 2008 and the Rating (1=low 6=high) of Corruption in 2012?
Provide a succinct answer. 0.09. What is the difference between the Rating (1=low 6=high) of Structural Policies in 2008 and the Rating (1=low 6=high) of Corruption in 2012?
Provide a succinct answer. 0.44. What is the difference between the Rating (1=low 6=high) in Social equity in 2008 and the Rating (1=low 6=high) in Environmental sustainability in 2013?
Offer a very short reply. 0.26. What is the difference between the Rating (1=low 6=high) in Social equity in 2008 and the Rating (1=low 6=high) in Structural Policies in 2013?
Offer a terse response. -0.03. What is the difference between the Rating (1=low 6=high) of Social equity in 2008 and the Rating (1=low 6=high) of Corruption in 2013?
Keep it short and to the point. 0.29. What is the difference between the Rating (1=low 6=high) of Environmental sustainability in 2008 and the Rating (1=low 6=high) of Structural Policies in 2013?
Give a very brief answer. -0.24. What is the difference between the Rating (1=low 6=high) in Environmental sustainability in 2008 and the Rating (1=low 6=high) in Corruption in 2013?
Offer a terse response. 0.07. What is the difference between the Rating (1=low 6=high) of Structural Policies in 2008 and the Rating (1=low 6=high) of Corruption in 2013?
Give a very brief answer. 0.42. What is the difference between the Rating (1=low 6=high) of Social equity in 2009 and the Rating (1=low 6=high) of Environmental sustainability in 2010?
Provide a short and direct response. 0.22. What is the difference between the Rating (1=low 6=high) in Social equity in 2009 and the Rating (1=low 6=high) in Structural Policies in 2010?
Your answer should be compact. -0.11. What is the difference between the Rating (1=low 6=high) in Social equity in 2009 and the Rating (1=low 6=high) in Corruption in 2010?
Provide a succinct answer. 0.41. What is the difference between the Rating (1=low 6=high) in Environmental sustainability in 2009 and the Rating (1=low 6=high) in Corruption in 2010?
Offer a very short reply. 0.18. What is the difference between the Rating (1=low 6=high) of Structural Policies in 2009 and the Rating (1=low 6=high) of Corruption in 2010?
Provide a short and direct response. 0.53. What is the difference between the Rating (1=low 6=high) in Social equity in 2009 and the Rating (1=low 6=high) in Environmental sustainability in 2011?
Your answer should be very brief. 0.29. What is the difference between the Rating (1=low 6=high) of Social equity in 2009 and the Rating (1=low 6=high) of Structural Policies in 2011?
Keep it short and to the point. -0.07. What is the difference between the Rating (1=low 6=high) of Social equity in 2009 and the Rating (1=low 6=high) of Corruption in 2011?
Your answer should be compact. 0.34. What is the difference between the Rating (1=low 6=high) in Environmental sustainability in 2009 and the Rating (1=low 6=high) in Structural Policies in 2011?
Provide a short and direct response. -0.29. What is the difference between the Rating (1=low 6=high) in Environmental sustainability in 2009 and the Rating (1=low 6=high) in Corruption in 2011?
Offer a very short reply. 0.11. What is the difference between the Rating (1=low 6=high) in Structural Policies in 2009 and the Rating (1=low 6=high) in Corruption in 2011?
Provide a succinct answer. 0.46. What is the difference between the Rating (1=low 6=high) in Social equity in 2009 and the Rating (1=low 6=high) in Environmental sustainability in 2012?
Your answer should be compact. 0.26. What is the difference between the Rating (1=low 6=high) in Social equity in 2009 and the Rating (1=low 6=high) in Structural Policies in 2012?
Give a very brief answer. -0.04. What is the difference between the Rating (1=low 6=high) of Social equity in 2009 and the Rating (1=low 6=high) of Corruption in 2012?
Ensure brevity in your answer.  0.31. What is the difference between the Rating (1=low 6=high) in Environmental sustainability in 2009 and the Rating (1=low 6=high) in Structural Policies in 2012?
Keep it short and to the point. -0.26. What is the difference between the Rating (1=low 6=high) in Environmental sustainability in 2009 and the Rating (1=low 6=high) in Corruption in 2012?
Make the answer very short. 0.09. What is the difference between the Rating (1=low 6=high) of Structural Policies in 2009 and the Rating (1=low 6=high) of Corruption in 2012?
Offer a terse response. 0.44. What is the difference between the Rating (1=low 6=high) of Social equity in 2009 and the Rating (1=low 6=high) of Environmental sustainability in 2013?
Your response must be concise. 0.26. What is the difference between the Rating (1=low 6=high) of Social equity in 2009 and the Rating (1=low 6=high) of Structural Policies in 2013?
Your response must be concise. -0.02. What is the difference between the Rating (1=low 6=high) of Social equity in 2009 and the Rating (1=low 6=high) of Corruption in 2013?
Make the answer very short. 0.29. What is the difference between the Rating (1=low 6=high) of Environmental sustainability in 2009 and the Rating (1=low 6=high) of Structural Policies in 2013?
Your answer should be very brief. -0.24. What is the difference between the Rating (1=low 6=high) of Environmental sustainability in 2009 and the Rating (1=low 6=high) of Corruption in 2013?
Offer a terse response. 0.07. What is the difference between the Rating (1=low 6=high) in Structural Policies in 2009 and the Rating (1=low 6=high) in Corruption in 2013?
Offer a very short reply. 0.42. What is the difference between the Rating (1=low 6=high) of Social equity in 2010 and the Rating (1=low 6=high) of Environmental sustainability in 2011?
Give a very brief answer. 0.31. What is the difference between the Rating (1=low 6=high) of Social equity in 2010 and the Rating (1=low 6=high) of Structural Policies in 2011?
Provide a short and direct response. -0.05. What is the difference between the Rating (1=low 6=high) in Social equity in 2010 and the Rating (1=low 6=high) in Corruption in 2011?
Your answer should be very brief. 0.36. What is the difference between the Rating (1=low 6=high) in Environmental sustainability in 2010 and the Rating (1=low 6=high) in Structural Policies in 2011?
Give a very brief answer. -0.29. What is the difference between the Rating (1=low 6=high) of Environmental sustainability in 2010 and the Rating (1=low 6=high) of Corruption in 2011?
Provide a succinct answer. 0.11. What is the difference between the Rating (1=low 6=high) of Structural Policies in 2010 and the Rating (1=low 6=high) of Corruption in 2011?
Offer a very short reply. 0.45. What is the difference between the Rating (1=low 6=high) of Social equity in 2010 and the Rating (1=low 6=high) of Environmental sustainability in 2012?
Make the answer very short. 0.28. What is the difference between the Rating (1=low 6=high) in Social equity in 2010 and the Rating (1=low 6=high) in Structural Policies in 2012?
Your answer should be very brief. -0.02. What is the difference between the Rating (1=low 6=high) in Social equity in 2010 and the Rating (1=low 6=high) in Corruption in 2012?
Provide a succinct answer. 0.33. What is the difference between the Rating (1=low 6=high) in Environmental sustainability in 2010 and the Rating (1=low 6=high) in Structural Policies in 2012?
Provide a short and direct response. -0.26. What is the difference between the Rating (1=low 6=high) of Environmental sustainability in 2010 and the Rating (1=low 6=high) of Corruption in 2012?
Offer a very short reply. 0.09. What is the difference between the Rating (1=low 6=high) in Structural Policies in 2010 and the Rating (1=low 6=high) in Corruption in 2012?
Offer a terse response. 0.42. What is the difference between the Rating (1=low 6=high) in Social equity in 2010 and the Rating (1=low 6=high) in Environmental sustainability in 2013?
Ensure brevity in your answer.  0.29. What is the difference between the Rating (1=low 6=high) in Social equity in 2010 and the Rating (1=low 6=high) in Structural Policies in 2013?
Your response must be concise. 0. What is the difference between the Rating (1=low 6=high) in Social equity in 2010 and the Rating (1=low 6=high) in Corruption in 2013?
Ensure brevity in your answer.  0.31. What is the difference between the Rating (1=low 6=high) of Environmental sustainability in 2010 and the Rating (1=low 6=high) of Structural Policies in 2013?
Offer a very short reply. -0.24. What is the difference between the Rating (1=low 6=high) of Environmental sustainability in 2010 and the Rating (1=low 6=high) of Corruption in 2013?
Make the answer very short. 0.07. What is the difference between the Rating (1=low 6=high) of Structural Policies in 2010 and the Rating (1=low 6=high) of Corruption in 2013?
Keep it short and to the point. 0.4. What is the difference between the Rating (1=low 6=high) of Social equity in 2011 and the Rating (1=low 6=high) of Environmental sustainability in 2012?
Your answer should be very brief. 0.24. What is the difference between the Rating (1=low 6=high) of Social equity in 2011 and the Rating (1=low 6=high) of Structural Policies in 2012?
Make the answer very short. -0.06. What is the difference between the Rating (1=low 6=high) of Social equity in 2011 and the Rating (1=low 6=high) of Corruption in 2012?
Make the answer very short. 0.28. What is the difference between the Rating (1=low 6=high) in Environmental sustainability in 2011 and the Rating (1=low 6=high) in Structural Policies in 2012?
Your answer should be compact. -0.32. What is the difference between the Rating (1=low 6=high) of Environmental sustainability in 2011 and the Rating (1=low 6=high) of Corruption in 2012?
Your answer should be compact. 0.02. What is the difference between the Rating (1=low 6=high) of Structural Policies in 2011 and the Rating (1=low 6=high) of Corruption in 2012?
Give a very brief answer. 0.38. What is the difference between the Rating (1=low 6=high) of Social equity in 2011 and the Rating (1=low 6=high) of Environmental sustainability in 2013?
Provide a short and direct response. 0.24. What is the difference between the Rating (1=low 6=high) of Social equity in 2011 and the Rating (1=low 6=high) of Structural Policies in 2013?
Keep it short and to the point. -0.05. What is the difference between the Rating (1=low 6=high) in Social equity in 2011 and the Rating (1=low 6=high) in Corruption in 2013?
Your answer should be compact. 0.27. What is the difference between the Rating (1=low 6=high) of Environmental sustainability in 2011 and the Rating (1=low 6=high) of Structural Policies in 2013?
Give a very brief answer. -0.31. What is the difference between the Rating (1=low 6=high) in Environmental sustainability in 2011 and the Rating (1=low 6=high) in Corruption in 2013?
Your answer should be compact. 0.01. What is the difference between the Rating (1=low 6=high) in Structural Policies in 2011 and the Rating (1=low 6=high) in Corruption in 2013?
Your answer should be compact. 0.36. What is the difference between the Rating (1=low 6=high) of Social equity in 2012 and the Rating (1=low 6=high) of Environmental sustainability in 2013?
Provide a short and direct response. 0.24. What is the difference between the Rating (1=low 6=high) of Social equity in 2012 and the Rating (1=low 6=high) of Structural Policies in 2013?
Make the answer very short. -0.04. What is the difference between the Rating (1=low 6=high) of Social equity in 2012 and the Rating (1=low 6=high) of Corruption in 2013?
Your answer should be compact. 0.27. What is the difference between the Rating (1=low 6=high) in Environmental sustainability in 2012 and the Rating (1=low 6=high) in Structural Policies in 2013?
Provide a short and direct response. -0.28. What is the difference between the Rating (1=low 6=high) in Environmental sustainability in 2012 and the Rating (1=low 6=high) in Corruption in 2013?
Make the answer very short. 0.03. What is the difference between the Rating (1=low 6=high) of Structural Policies in 2012 and the Rating (1=low 6=high) of Corruption in 2013?
Offer a terse response. 0.33. What is the average Rating (1=low 6=high) of Social equity per year?
Offer a very short reply. 3.41. What is the average Rating (1=low 6=high) of Environmental sustainability per year?
Offer a very short reply. 3.18. What is the average Rating (1=low 6=high) in Structural Policies per year?
Make the answer very short. 3.51. What is the average Rating (1=low 6=high) in Corruption per year?
Offer a terse response. 3.06. In the year 2005, what is the difference between the Rating (1=low 6=high) of Social equity and Rating (1=low 6=high) of Environmental sustainability?
Offer a very short reply. 0.2. In the year 2005, what is the difference between the Rating (1=low 6=high) of Social equity and Rating (1=low 6=high) of Structural Policies?
Your response must be concise. -0.12. In the year 2005, what is the difference between the Rating (1=low 6=high) in Social equity and Rating (1=low 6=high) in Corruption?
Provide a short and direct response. 0.4. In the year 2005, what is the difference between the Rating (1=low 6=high) in Environmental sustainability and Rating (1=low 6=high) in Structural Policies?
Your answer should be very brief. -0.32. In the year 2005, what is the difference between the Rating (1=low 6=high) of Structural Policies and Rating (1=low 6=high) of Corruption?
Ensure brevity in your answer.  0.52. In the year 2006, what is the difference between the Rating (1=low 6=high) in Social equity and Rating (1=low 6=high) in Environmental sustainability?
Make the answer very short. 0.21. In the year 2006, what is the difference between the Rating (1=low 6=high) of Social equity and Rating (1=low 6=high) of Structural Policies?
Give a very brief answer. -0.13. In the year 2006, what is the difference between the Rating (1=low 6=high) in Social equity and Rating (1=low 6=high) in Corruption?
Offer a very short reply. 0.37. In the year 2006, what is the difference between the Rating (1=low 6=high) in Environmental sustainability and Rating (1=low 6=high) in Structural Policies?
Your answer should be very brief. -0.34. In the year 2006, what is the difference between the Rating (1=low 6=high) in Environmental sustainability and Rating (1=low 6=high) in Corruption?
Provide a short and direct response. 0.16. In the year 2006, what is the difference between the Rating (1=low 6=high) of Structural Policies and Rating (1=low 6=high) of Corruption?
Keep it short and to the point. 0.5. In the year 2007, what is the difference between the Rating (1=low 6=high) in Social equity and Rating (1=low 6=high) in Environmental sustainability?
Ensure brevity in your answer.  0.19. In the year 2007, what is the difference between the Rating (1=low 6=high) in Social equity and Rating (1=low 6=high) in Structural Policies?
Your answer should be compact. -0.16. In the year 2007, what is the difference between the Rating (1=low 6=high) of Social equity and Rating (1=low 6=high) of Corruption?
Offer a very short reply. 0.35. In the year 2007, what is the difference between the Rating (1=low 6=high) of Environmental sustainability and Rating (1=low 6=high) of Structural Policies?
Keep it short and to the point. -0.34. In the year 2007, what is the difference between the Rating (1=low 6=high) of Structural Policies and Rating (1=low 6=high) of Corruption?
Offer a very short reply. 0.51. In the year 2008, what is the difference between the Rating (1=low 6=high) in Social equity and Rating (1=low 6=high) in Environmental sustainability?
Offer a very short reply. 0.21. In the year 2008, what is the difference between the Rating (1=low 6=high) in Social equity and Rating (1=low 6=high) in Structural Policies?
Provide a short and direct response. -0.13. In the year 2008, what is the difference between the Rating (1=low 6=high) of Social equity and Rating (1=low 6=high) of Corruption?
Make the answer very short. 0.38. In the year 2008, what is the difference between the Rating (1=low 6=high) of Environmental sustainability and Rating (1=low 6=high) of Structural Policies?
Your response must be concise. -0.35. In the year 2008, what is the difference between the Rating (1=low 6=high) in Structural Policies and Rating (1=low 6=high) in Corruption?
Offer a terse response. 0.51. In the year 2009, what is the difference between the Rating (1=low 6=high) in Social equity and Rating (1=low 6=high) in Environmental sustainability?
Ensure brevity in your answer.  0.22. In the year 2009, what is the difference between the Rating (1=low 6=high) of Social equity and Rating (1=low 6=high) of Structural Policies?
Make the answer very short. -0.13. In the year 2009, what is the difference between the Rating (1=low 6=high) in Social equity and Rating (1=low 6=high) in Corruption?
Your answer should be very brief. 0.38. In the year 2009, what is the difference between the Rating (1=low 6=high) in Environmental sustainability and Rating (1=low 6=high) in Structural Policies?
Give a very brief answer. -0.35. In the year 2009, what is the difference between the Rating (1=low 6=high) in Environmental sustainability and Rating (1=low 6=high) in Corruption?
Your answer should be compact. 0.15. In the year 2009, what is the difference between the Rating (1=low 6=high) in Structural Policies and Rating (1=low 6=high) in Corruption?
Offer a terse response. 0.5. In the year 2010, what is the difference between the Rating (1=low 6=high) of Social equity and Rating (1=low 6=high) of Environmental sustainability?
Keep it short and to the point. 0.24. In the year 2010, what is the difference between the Rating (1=low 6=high) of Social equity and Rating (1=low 6=high) of Structural Policies?
Provide a short and direct response. -0.09. In the year 2010, what is the difference between the Rating (1=low 6=high) of Social equity and Rating (1=low 6=high) of Corruption?
Ensure brevity in your answer.  0.43. In the year 2010, what is the difference between the Rating (1=low 6=high) of Environmental sustainability and Rating (1=low 6=high) of Corruption?
Provide a succinct answer. 0.18. In the year 2010, what is the difference between the Rating (1=low 6=high) of Structural Policies and Rating (1=low 6=high) of Corruption?
Your answer should be very brief. 0.52. In the year 2011, what is the difference between the Rating (1=low 6=high) in Social equity and Rating (1=low 6=high) in Environmental sustainability?
Your answer should be very brief. 0.26. In the year 2011, what is the difference between the Rating (1=low 6=high) of Social equity and Rating (1=low 6=high) of Structural Policies?
Make the answer very short. -0.09. In the year 2011, what is the difference between the Rating (1=low 6=high) in Social equity and Rating (1=low 6=high) in Corruption?
Give a very brief answer. 0.31. In the year 2011, what is the difference between the Rating (1=low 6=high) in Environmental sustainability and Rating (1=low 6=high) in Structural Policies?
Your answer should be compact. -0.36. In the year 2011, what is the difference between the Rating (1=low 6=high) of Environmental sustainability and Rating (1=low 6=high) of Corruption?
Your response must be concise. 0.05. In the year 2011, what is the difference between the Rating (1=low 6=high) of Structural Policies and Rating (1=low 6=high) of Corruption?
Provide a short and direct response. 0.41. In the year 2012, what is the difference between the Rating (1=low 6=high) in Social equity and Rating (1=low 6=high) in Environmental sustainability?
Give a very brief answer. 0.24. In the year 2012, what is the difference between the Rating (1=low 6=high) of Social equity and Rating (1=low 6=high) of Structural Policies?
Offer a very short reply. -0.06. In the year 2012, what is the difference between the Rating (1=low 6=high) of Social equity and Rating (1=low 6=high) of Corruption?
Make the answer very short. 0.29. In the year 2012, what is the difference between the Rating (1=low 6=high) in Environmental sustainability and Rating (1=low 6=high) in Structural Policies?
Offer a terse response. -0.3. In the year 2012, what is the difference between the Rating (1=low 6=high) of Environmental sustainability and Rating (1=low 6=high) of Corruption?
Keep it short and to the point. 0.05. In the year 2012, what is the difference between the Rating (1=low 6=high) in Structural Policies and Rating (1=low 6=high) in Corruption?
Make the answer very short. 0.35. In the year 2013, what is the difference between the Rating (1=low 6=high) of Social equity and Rating (1=low 6=high) of Environmental sustainability?
Your answer should be very brief. 0.23. In the year 2013, what is the difference between the Rating (1=low 6=high) in Social equity and Rating (1=low 6=high) in Structural Policies?
Keep it short and to the point. -0.06. In the year 2013, what is the difference between the Rating (1=low 6=high) of Social equity and Rating (1=low 6=high) of Corruption?
Your answer should be very brief. 0.26. In the year 2013, what is the difference between the Rating (1=low 6=high) in Environmental sustainability and Rating (1=low 6=high) in Structural Policies?
Ensure brevity in your answer.  -0.29. In the year 2013, what is the difference between the Rating (1=low 6=high) in Environmental sustainability and Rating (1=low 6=high) in Corruption?
Give a very brief answer. 0.03. In the year 2013, what is the difference between the Rating (1=low 6=high) of Structural Policies and Rating (1=low 6=high) of Corruption?
Offer a terse response. 0.31. What is the ratio of the Rating (1=low 6=high) of Social equity in 2005 to that in 2006?
Provide a succinct answer. 1.01. What is the ratio of the Rating (1=low 6=high) in Environmental sustainability in 2005 to that in 2006?
Offer a very short reply. 1.01. What is the ratio of the Rating (1=low 6=high) of Structural Policies in 2005 to that in 2006?
Give a very brief answer. 1.01. What is the ratio of the Rating (1=low 6=high) in Social equity in 2005 to that in 2007?
Give a very brief answer. 1. What is the ratio of the Rating (1=low 6=high) of Corruption in 2005 to that in 2007?
Make the answer very short. 0.99. What is the ratio of the Rating (1=low 6=high) of Environmental sustainability in 2005 to that in 2008?
Provide a succinct answer. 1. What is the ratio of the Rating (1=low 6=high) in Corruption in 2005 to that in 2008?
Keep it short and to the point. 0.99. What is the ratio of the Rating (1=low 6=high) in Structural Policies in 2005 to that in 2009?
Give a very brief answer. 0.99. What is the ratio of the Rating (1=low 6=high) in Corruption in 2005 to that in 2009?
Your response must be concise. 0.98. What is the ratio of the Rating (1=low 6=high) of Social equity in 2005 to that in 2010?
Offer a terse response. 0.98. What is the ratio of the Rating (1=low 6=high) of Environmental sustainability in 2005 to that in 2010?
Offer a terse response. 1. What is the ratio of the Rating (1=low 6=high) of Structural Policies in 2005 to that in 2010?
Ensure brevity in your answer.  1. What is the ratio of the Rating (1=low 6=high) in Social equity in 2005 to that in 2011?
Give a very brief answer. 1. What is the ratio of the Rating (1=low 6=high) of Environmental sustainability in 2005 to that in 2011?
Keep it short and to the point. 1.02. What is the ratio of the Rating (1=low 6=high) in Structural Policies in 2005 to that in 2011?
Your answer should be compact. 1.01. What is the ratio of the Rating (1=low 6=high) in Corruption in 2005 to that in 2011?
Provide a short and direct response. 0.97. What is the ratio of the Rating (1=low 6=high) in Social equity in 2005 to that in 2012?
Your answer should be very brief. 1. What is the ratio of the Rating (1=low 6=high) of Environmental sustainability in 2005 to that in 2012?
Provide a succinct answer. 1.01. What is the ratio of the Rating (1=low 6=high) of Structural Policies in 2005 to that in 2012?
Keep it short and to the point. 1.02. What is the ratio of the Rating (1=low 6=high) in Corruption in 2005 to that in 2012?
Ensure brevity in your answer.  0.96. What is the ratio of the Rating (1=low 6=high) in Environmental sustainability in 2005 to that in 2013?
Provide a succinct answer. 1.01. What is the ratio of the Rating (1=low 6=high) of Structural Policies in 2005 to that in 2013?
Ensure brevity in your answer.  1.02. What is the ratio of the Rating (1=low 6=high) in Corruption in 2005 to that in 2013?
Your response must be concise. 0.96. What is the ratio of the Rating (1=low 6=high) of Social equity in 2006 to that in 2007?
Make the answer very short. 0.99. What is the ratio of the Rating (1=low 6=high) of Structural Policies in 2006 to that in 2007?
Give a very brief answer. 0.98. What is the ratio of the Rating (1=low 6=high) in Corruption in 2006 to that in 2007?
Offer a terse response. 0.99. What is the ratio of the Rating (1=low 6=high) of Social equity in 2006 to that in 2008?
Your response must be concise. 0.98. What is the ratio of the Rating (1=low 6=high) in Environmental sustainability in 2006 to that in 2008?
Your answer should be compact. 0.98. What is the ratio of the Rating (1=low 6=high) of Structural Policies in 2006 to that in 2008?
Keep it short and to the point. 0.98. What is the ratio of the Rating (1=low 6=high) in Corruption in 2006 to that in 2008?
Your answer should be very brief. 0.99. What is the ratio of the Rating (1=low 6=high) of Social equity in 2006 to that in 2009?
Give a very brief answer. 0.98. What is the ratio of the Rating (1=low 6=high) of Environmental sustainability in 2006 to that in 2009?
Make the answer very short. 0.99. What is the ratio of the Rating (1=low 6=high) in Structural Policies in 2006 to that in 2009?
Give a very brief answer. 0.98. What is the ratio of the Rating (1=low 6=high) of Corruption in 2006 to that in 2009?
Offer a terse response. 0.98. What is the ratio of the Rating (1=low 6=high) of Social equity in 2006 to that in 2010?
Offer a terse response. 0.98. What is the ratio of the Rating (1=low 6=high) of Environmental sustainability in 2006 to that in 2010?
Your response must be concise. 0.99. What is the ratio of the Rating (1=low 6=high) in Structural Policies in 2006 to that in 2010?
Offer a terse response. 0.99. What is the ratio of the Rating (1=low 6=high) of Corruption in 2006 to that in 2010?
Make the answer very short. 0.99. What is the ratio of the Rating (1=low 6=high) of Social equity in 2006 to that in 2011?
Ensure brevity in your answer.  0.99. What is the ratio of the Rating (1=low 6=high) of Environmental sustainability in 2006 to that in 2011?
Give a very brief answer. 1.01. What is the ratio of the Rating (1=low 6=high) of Corruption in 2006 to that in 2011?
Provide a short and direct response. 0.97. What is the ratio of the Rating (1=low 6=high) of Social equity in 2006 to that in 2012?
Your answer should be very brief. 0.99. What is the ratio of the Rating (1=low 6=high) of Environmental sustainability in 2006 to that in 2012?
Provide a succinct answer. 1. What is the ratio of the Rating (1=low 6=high) of Structural Policies in 2006 to that in 2012?
Your answer should be compact. 1.01. What is the ratio of the Rating (1=low 6=high) in Corruption in 2006 to that in 2012?
Offer a terse response. 0.96. What is the ratio of the Rating (1=low 6=high) of Social equity in 2006 to that in 2013?
Provide a short and direct response. 0.99. What is the ratio of the Rating (1=low 6=high) in Environmental sustainability in 2006 to that in 2013?
Offer a very short reply. 1. What is the ratio of the Rating (1=low 6=high) in Structural Policies in 2006 to that in 2013?
Your answer should be very brief. 1.01. What is the ratio of the Rating (1=low 6=high) of Corruption in 2006 to that in 2013?
Provide a succinct answer. 0.96. What is the ratio of the Rating (1=low 6=high) of Structural Policies in 2007 to that in 2008?
Provide a short and direct response. 1. What is the ratio of the Rating (1=low 6=high) in Social equity in 2007 to that in 2009?
Offer a very short reply. 0.99. What is the ratio of the Rating (1=low 6=high) in Environmental sustainability in 2007 to that in 2009?
Offer a very short reply. 1. What is the ratio of the Rating (1=low 6=high) in Structural Policies in 2007 to that in 2009?
Keep it short and to the point. 1. What is the ratio of the Rating (1=low 6=high) in Social equity in 2007 to that in 2010?
Provide a short and direct response. 0.98. What is the ratio of the Rating (1=low 6=high) in Structural Policies in 2007 to that in 2010?
Keep it short and to the point. 1. What is the ratio of the Rating (1=low 6=high) of Environmental sustainability in 2007 to that in 2011?
Your answer should be very brief. 1.02. What is the ratio of the Rating (1=low 6=high) in Structural Policies in 2007 to that in 2011?
Keep it short and to the point. 1.02. What is the ratio of the Rating (1=low 6=high) in Corruption in 2007 to that in 2011?
Your answer should be very brief. 0.98. What is the ratio of the Rating (1=low 6=high) in Environmental sustainability in 2007 to that in 2012?
Your answer should be compact. 1.01. What is the ratio of the Rating (1=low 6=high) in Structural Policies in 2007 to that in 2012?
Make the answer very short. 1.03. What is the ratio of the Rating (1=low 6=high) of Corruption in 2007 to that in 2012?
Give a very brief answer. 0.98. What is the ratio of the Rating (1=low 6=high) in Environmental sustainability in 2007 to that in 2013?
Provide a short and direct response. 1.01. What is the ratio of the Rating (1=low 6=high) in Structural Policies in 2007 to that in 2013?
Keep it short and to the point. 1.03. What is the ratio of the Rating (1=low 6=high) in Corruption in 2007 to that in 2013?
Your answer should be compact. 0.97. What is the ratio of the Rating (1=low 6=high) in Structural Policies in 2008 to that in 2009?
Make the answer very short. 1. What is the ratio of the Rating (1=low 6=high) of Corruption in 2008 to that in 2009?
Offer a terse response. 1. What is the ratio of the Rating (1=low 6=high) of Social equity in 2008 to that in 2010?
Offer a terse response. 0.99. What is the ratio of the Rating (1=low 6=high) of Environmental sustainability in 2008 to that in 2011?
Give a very brief answer. 1.02. What is the ratio of the Rating (1=low 6=high) of Structural Policies in 2008 to that in 2011?
Make the answer very short. 1.02. What is the ratio of the Rating (1=low 6=high) in Corruption in 2008 to that in 2011?
Your response must be concise. 0.98. What is the ratio of the Rating (1=low 6=high) in Environmental sustainability in 2008 to that in 2012?
Offer a very short reply. 1.01. What is the ratio of the Rating (1=low 6=high) in Structural Policies in 2008 to that in 2012?
Provide a succinct answer. 1.03. What is the ratio of the Rating (1=low 6=high) of Corruption in 2008 to that in 2012?
Ensure brevity in your answer.  0.98. What is the ratio of the Rating (1=low 6=high) in Environmental sustainability in 2008 to that in 2013?
Ensure brevity in your answer.  1.01. What is the ratio of the Rating (1=low 6=high) of Structural Policies in 2008 to that in 2013?
Offer a terse response. 1.03. What is the ratio of the Rating (1=low 6=high) of Corruption in 2008 to that in 2013?
Ensure brevity in your answer.  0.97. What is the ratio of the Rating (1=low 6=high) in Environmental sustainability in 2009 to that in 2010?
Keep it short and to the point. 1. What is the ratio of the Rating (1=low 6=high) of Environmental sustainability in 2009 to that in 2011?
Offer a very short reply. 1.02. What is the ratio of the Rating (1=low 6=high) of Structural Policies in 2009 to that in 2011?
Your answer should be compact. 1.02. What is the ratio of the Rating (1=low 6=high) in Corruption in 2009 to that in 2011?
Ensure brevity in your answer.  0.99. What is the ratio of the Rating (1=low 6=high) in Social equity in 2009 to that in 2012?
Provide a short and direct response. 1.01. What is the ratio of the Rating (1=low 6=high) in Environmental sustainability in 2009 to that in 2012?
Your answer should be compact. 1.01. What is the ratio of the Rating (1=low 6=high) in Structural Policies in 2009 to that in 2012?
Provide a short and direct response. 1.03. What is the ratio of the Rating (1=low 6=high) of Corruption in 2009 to that in 2012?
Make the answer very short. 0.98. What is the ratio of the Rating (1=low 6=high) of Social equity in 2009 to that in 2013?
Provide a short and direct response. 1.01. What is the ratio of the Rating (1=low 6=high) in Environmental sustainability in 2009 to that in 2013?
Keep it short and to the point. 1.01. What is the ratio of the Rating (1=low 6=high) in Structural Policies in 2009 to that in 2013?
Keep it short and to the point. 1.03. What is the ratio of the Rating (1=low 6=high) of Corruption in 2009 to that in 2013?
Your answer should be compact. 0.97. What is the ratio of the Rating (1=low 6=high) of Social equity in 2010 to that in 2011?
Keep it short and to the point. 1.01. What is the ratio of the Rating (1=low 6=high) of Environmental sustainability in 2010 to that in 2011?
Your response must be concise. 1.02. What is the ratio of the Rating (1=low 6=high) in Structural Policies in 2010 to that in 2011?
Your answer should be very brief. 1.01. What is the ratio of the Rating (1=low 6=high) of Corruption in 2010 to that in 2011?
Provide a succinct answer. 0.98. What is the ratio of the Rating (1=low 6=high) of Social equity in 2010 to that in 2012?
Keep it short and to the point. 1.01. What is the ratio of the Rating (1=low 6=high) in Environmental sustainability in 2010 to that in 2012?
Your response must be concise. 1.01. What is the ratio of the Rating (1=low 6=high) of Structural Policies in 2010 to that in 2012?
Your response must be concise. 1.02. What is the ratio of the Rating (1=low 6=high) of Corruption in 2010 to that in 2012?
Provide a short and direct response. 0.97. What is the ratio of the Rating (1=low 6=high) in Social equity in 2010 to that in 2013?
Provide a succinct answer. 1.02. What is the ratio of the Rating (1=low 6=high) of Environmental sustainability in 2010 to that in 2013?
Give a very brief answer. 1.01. What is the ratio of the Rating (1=low 6=high) in Structural Policies in 2010 to that in 2013?
Your answer should be compact. 1.03. What is the ratio of the Rating (1=low 6=high) in Corruption in 2010 to that in 2013?
Provide a short and direct response. 0.96. What is the ratio of the Rating (1=low 6=high) of Social equity in 2011 to that in 2012?
Keep it short and to the point. 1. What is the ratio of the Rating (1=low 6=high) in Structural Policies in 2011 to that in 2012?
Provide a short and direct response. 1.01. What is the ratio of the Rating (1=low 6=high) of Corruption in 2011 to that in 2012?
Your answer should be very brief. 0.99. What is the ratio of the Rating (1=low 6=high) in Social equity in 2011 to that in 2013?
Offer a very short reply. 1. What is the ratio of the Rating (1=low 6=high) of Environmental sustainability in 2011 to that in 2013?
Make the answer very short. 0.99. What is the ratio of the Rating (1=low 6=high) in Structural Policies in 2011 to that in 2013?
Offer a terse response. 1.01. What is the ratio of the Rating (1=low 6=high) in Corruption in 2011 to that in 2013?
Provide a short and direct response. 0.99. What is the ratio of the Rating (1=low 6=high) in Social equity in 2012 to that in 2013?
Provide a succinct answer. 1. What is the ratio of the Rating (1=low 6=high) in Environmental sustainability in 2012 to that in 2013?
Give a very brief answer. 1. What is the difference between the highest and the second highest Rating (1=low 6=high) in Social equity?
Your answer should be compact. 0.02. What is the difference between the highest and the second highest Rating (1=low 6=high) in Environmental sustainability?
Offer a terse response. 0. What is the difference between the highest and the second highest Rating (1=low 6=high) of Structural Policies?
Offer a terse response. 0. What is the difference between the highest and the second highest Rating (1=low 6=high) in Corruption?
Ensure brevity in your answer.  0.02. What is the difference between the highest and the lowest Rating (1=low 6=high) of Social equity?
Offer a very short reply. 0.08. What is the difference between the highest and the lowest Rating (1=low 6=high) of Environmental sustainability?
Provide a succinct answer. 0.07. What is the difference between the highest and the lowest Rating (1=low 6=high) in Structural Policies?
Provide a short and direct response. 0.11. What is the difference between the highest and the lowest Rating (1=low 6=high) in Corruption?
Offer a very short reply. 0.13. 